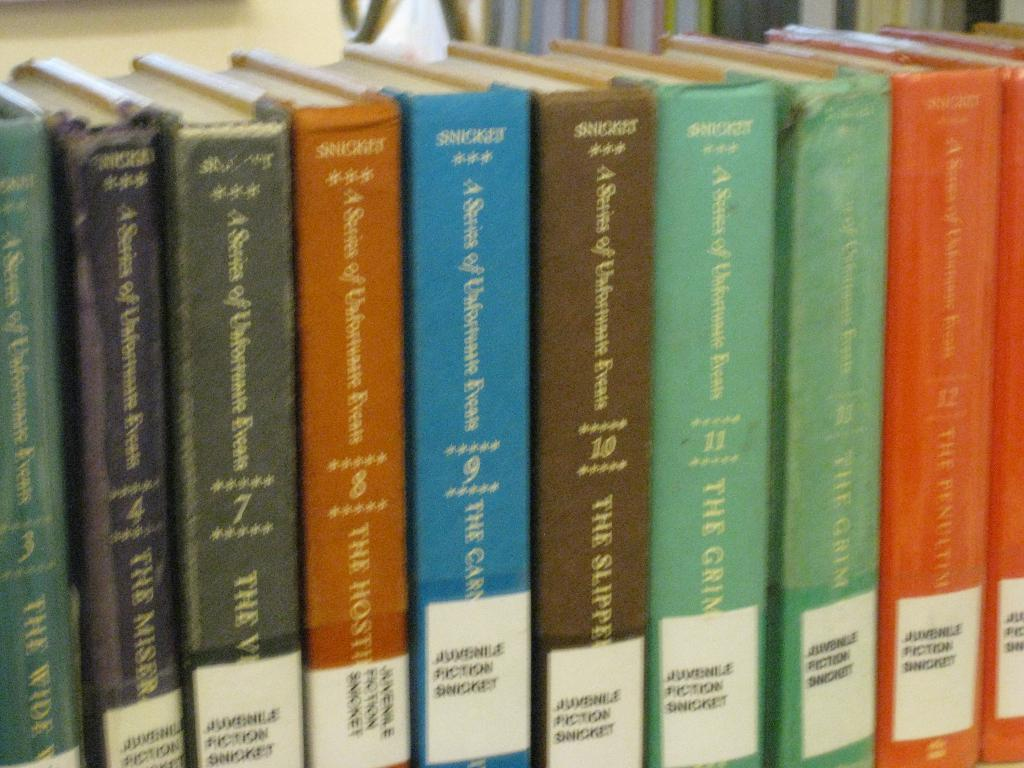<image>
Render a clear and concise summary of the photo. Volumes 3 through 12 of A Series of Unfortunate Events are lined up on a library shelf. 